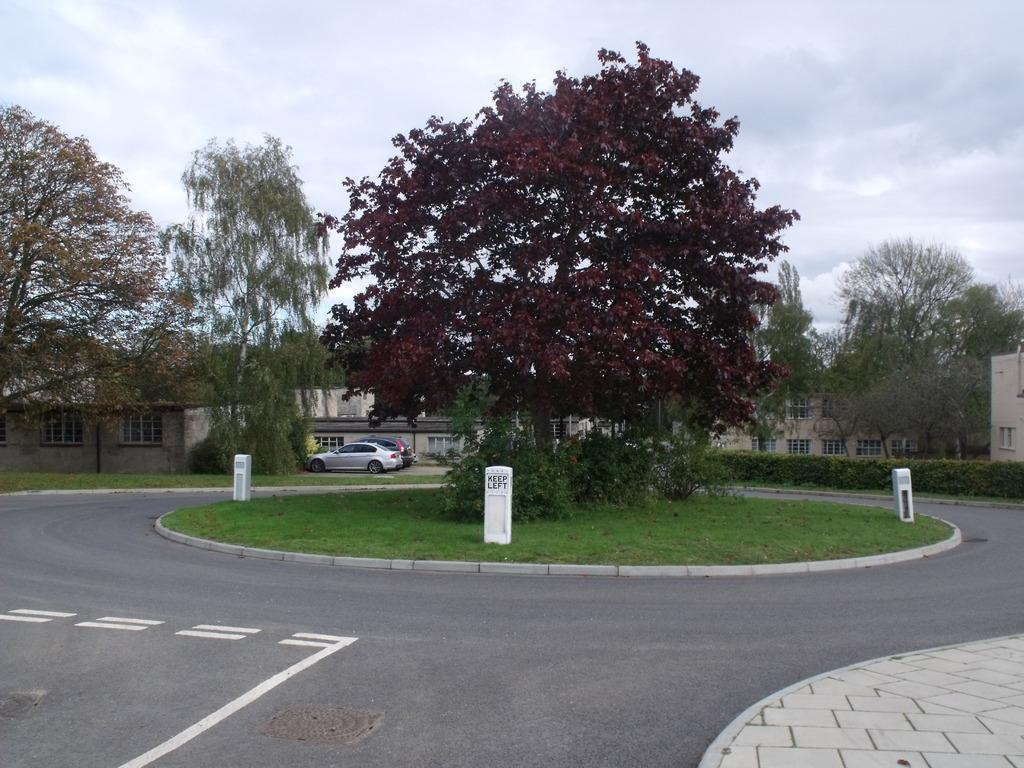Can you describe this image briefly? In this image, we can see the ground. We can see some grass and white colored objects. There are a few trees and vehicles. We can also see some buildings. We can see the sky with clouds. 